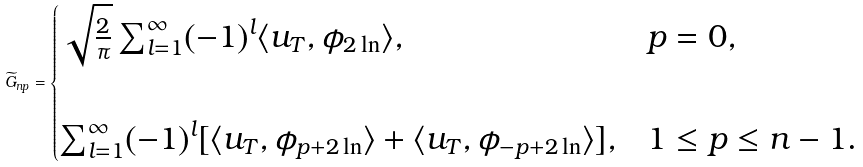Convert formula to latex. <formula><loc_0><loc_0><loc_500><loc_500>\widetilde { G } _ { n p } = \begin{cases} \sqrt { \frac { 2 } { \pi } } \sum _ { l = 1 } ^ { \infty } ( - 1 ) ^ { l } \langle u _ { T } , \phi _ { 2 \ln } \rangle , & p = 0 , \\ \\ \sum _ { l = 1 } ^ { \infty } ( - 1 ) ^ { l } [ \langle u _ { T } , \phi _ { p + 2 \ln } \rangle + \langle u _ { T } , \phi _ { - p + 2 \ln } \rangle ] , & 1 \leq p \leq n - 1 . \end{cases}</formula> 